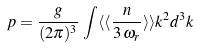<formula> <loc_0><loc_0><loc_500><loc_500>p = \frac { g } { ( 2 \pi ) ^ { 3 } } \, \int \langle \langle \frac { n } { 3 \, \omega _ { r } } \rangle \rangle k ^ { 2 } d ^ { 3 } k</formula> 